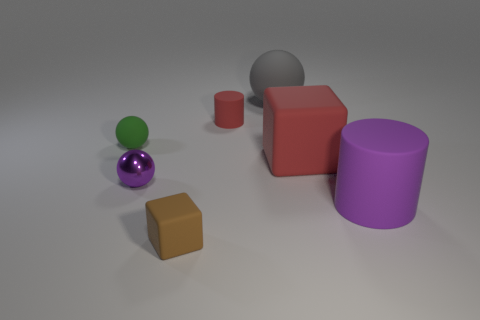Subtract all tiny rubber balls. How many balls are left? 2 Add 1 small brown spheres. How many objects exist? 8 Subtract all cylinders. How many objects are left? 5 Add 2 cyan things. How many cyan things exist? 2 Subtract 0 cyan spheres. How many objects are left? 7 Subtract all large matte balls. Subtract all brown things. How many objects are left? 5 Add 6 small green balls. How many small green balls are left? 7 